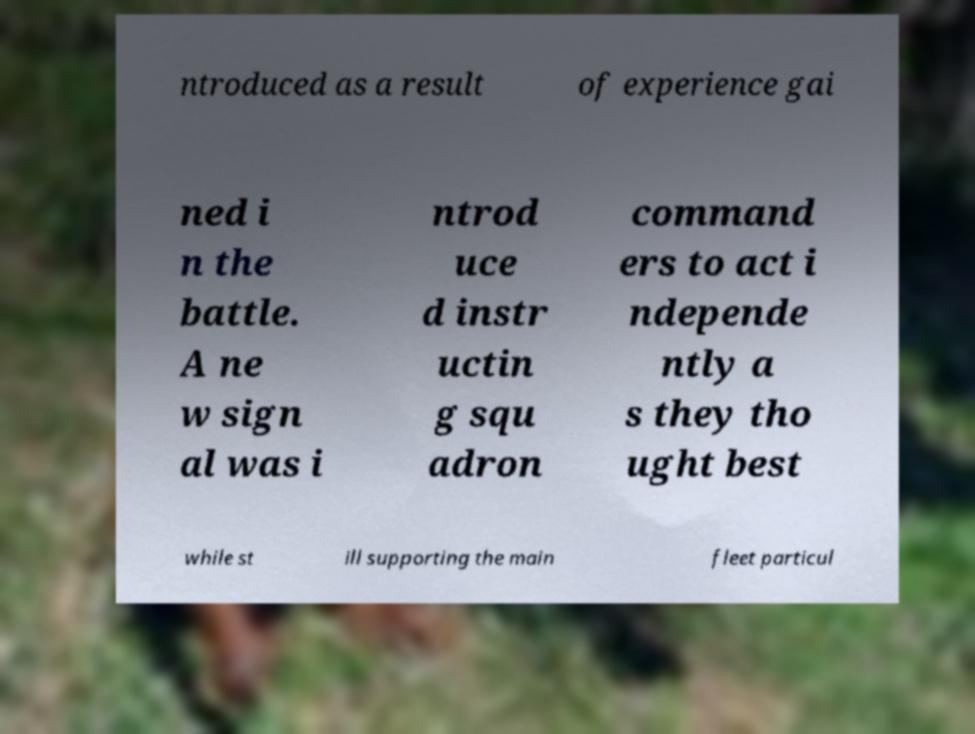Could you extract and type out the text from this image? ntroduced as a result of experience gai ned i n the battle. A ne w sign al was i ntrod uce d instr uctin g squ adron command ers to act i ndepende ntly a s they tho ught best while st ill supporting the main fleet particul 